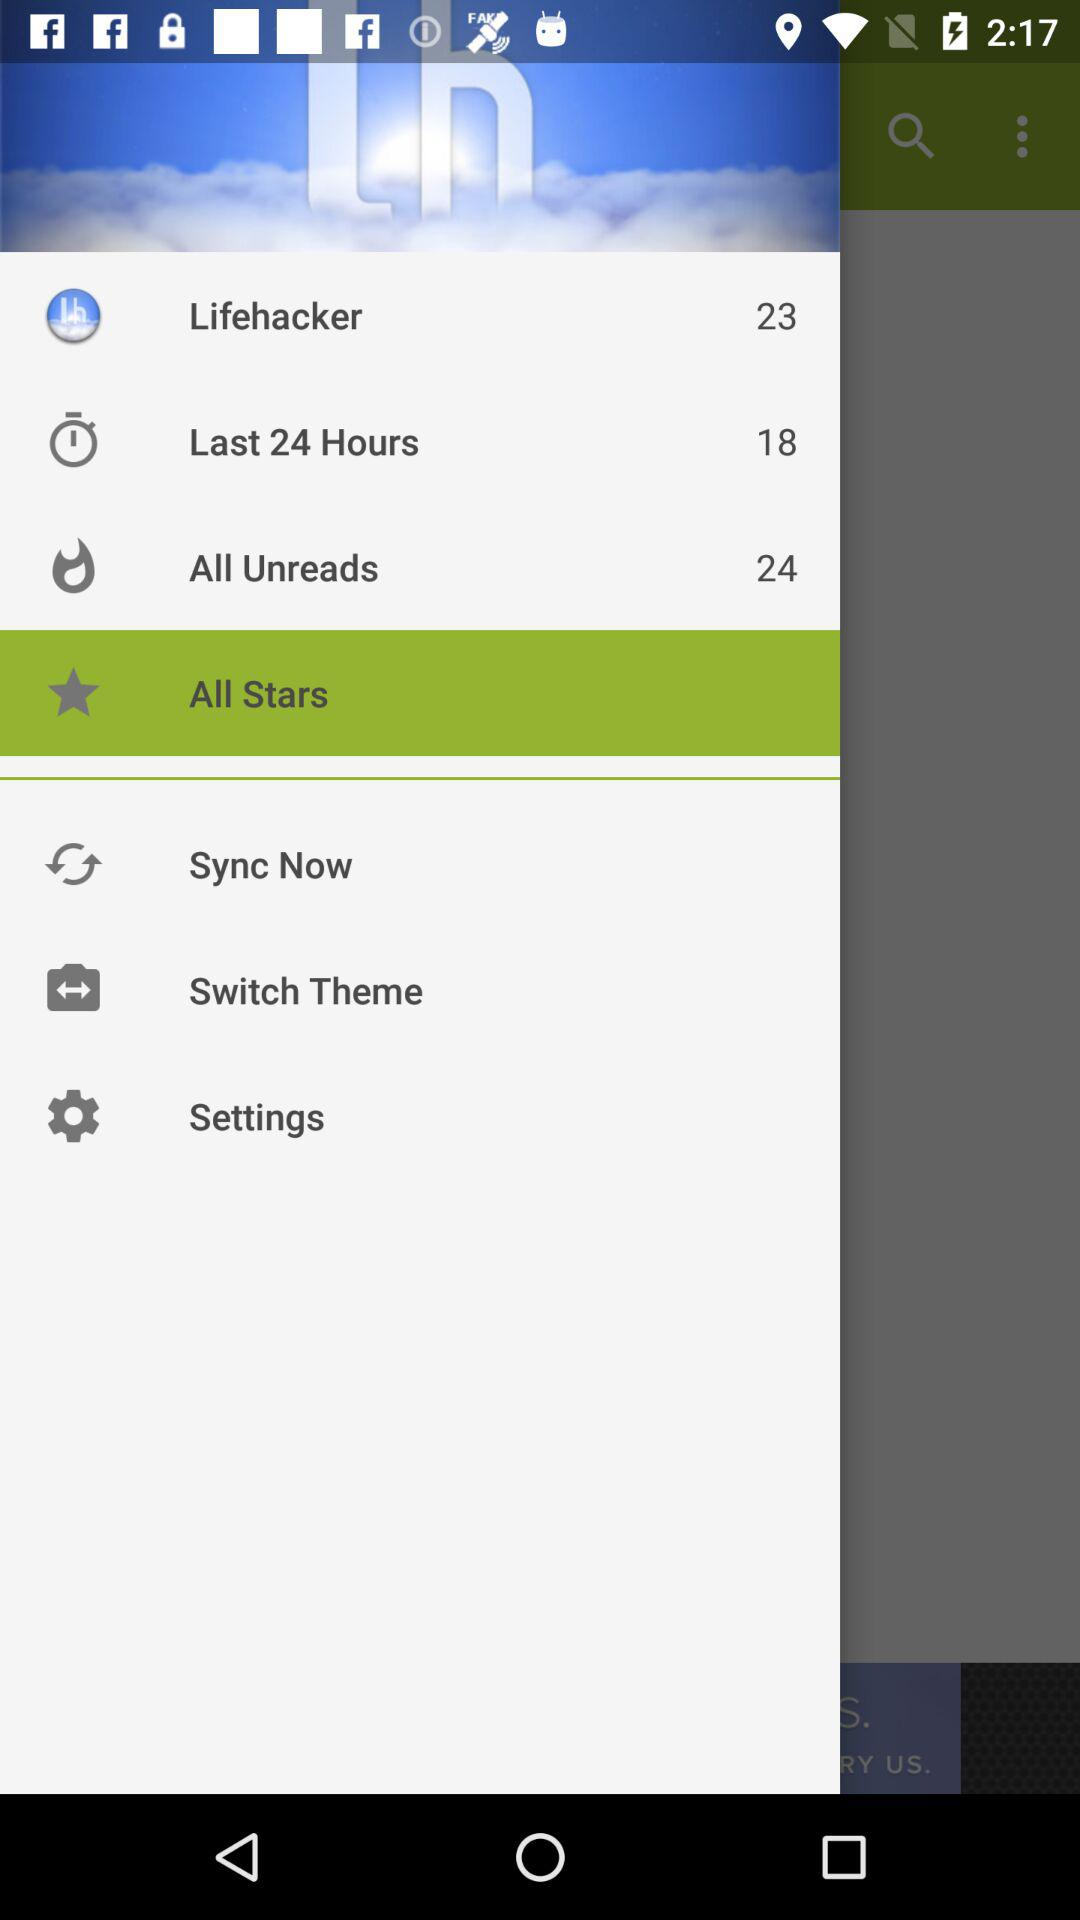How many lifehackers are there? There are 23 lifehackers. 